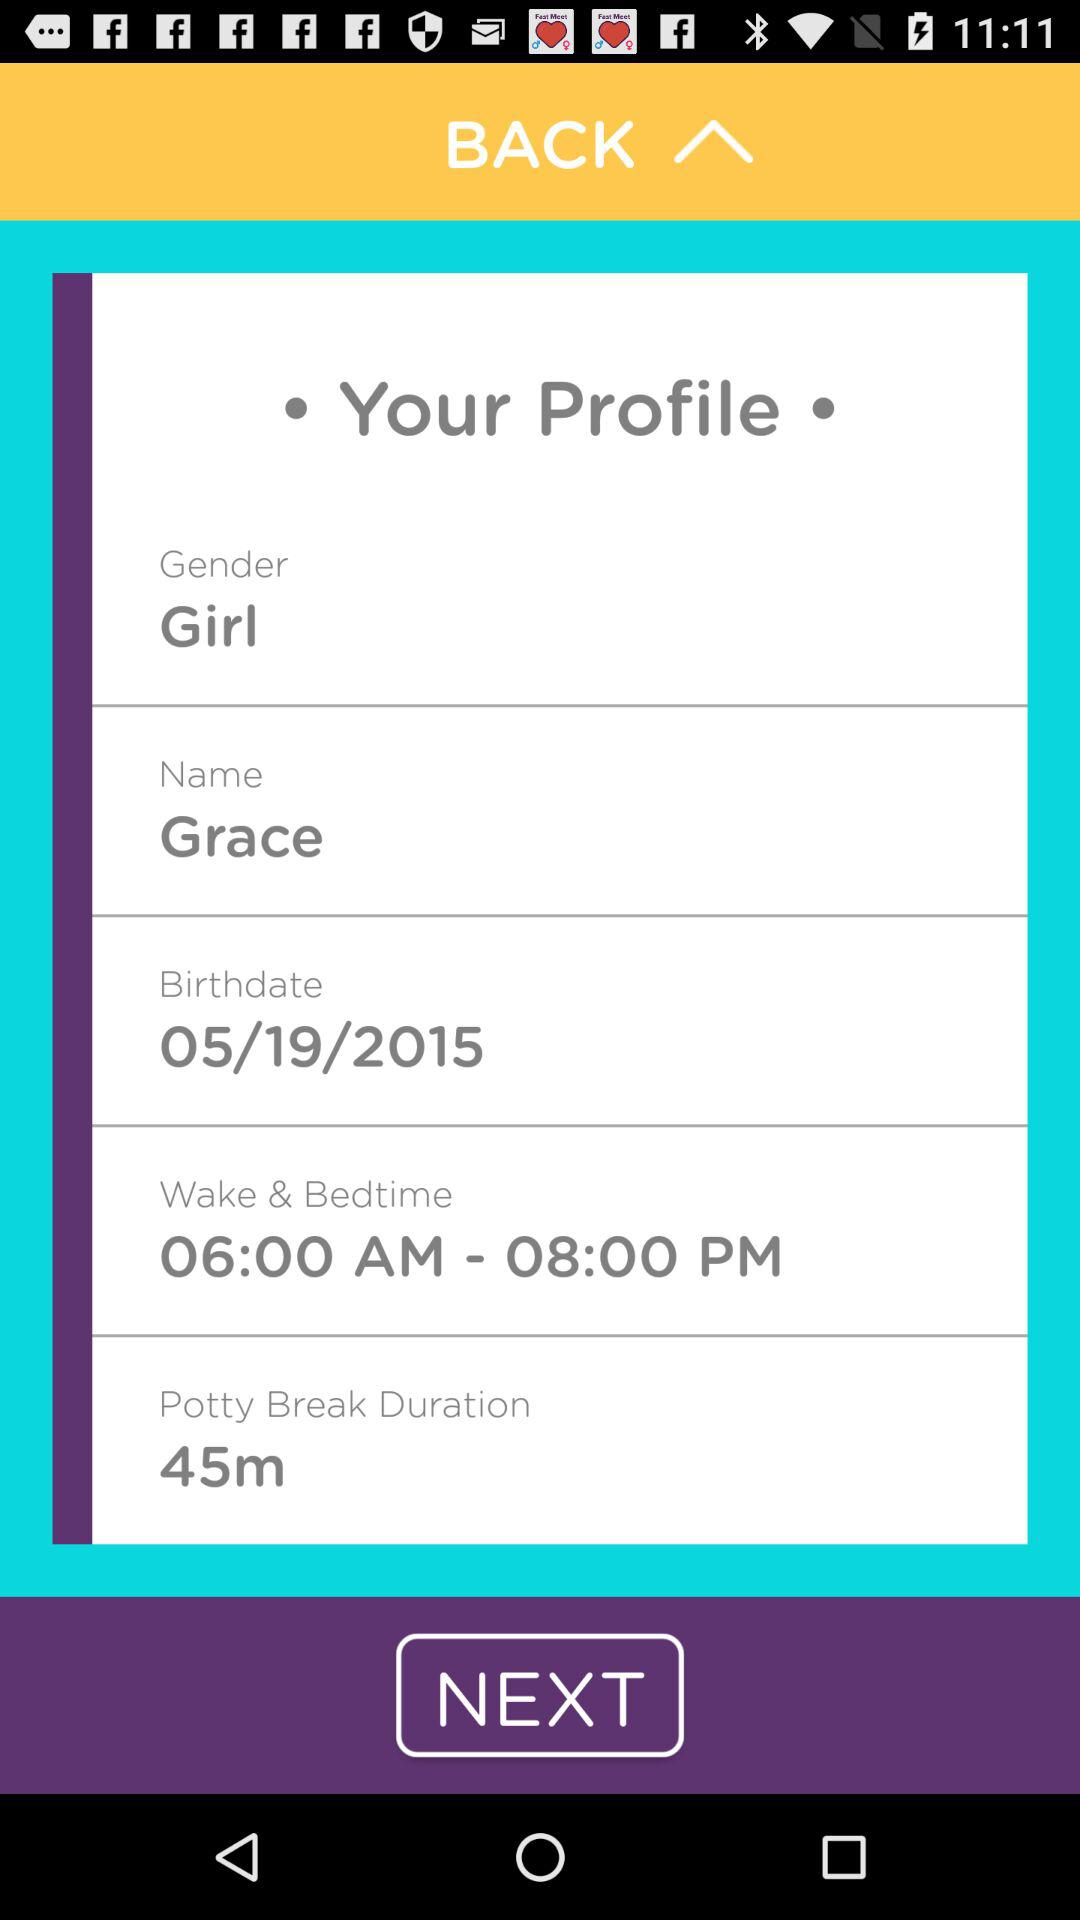What is the wake-up time and bedtime? The wake-up time and bedtime are 6:00 AM and 8:00 PM, respectively. 